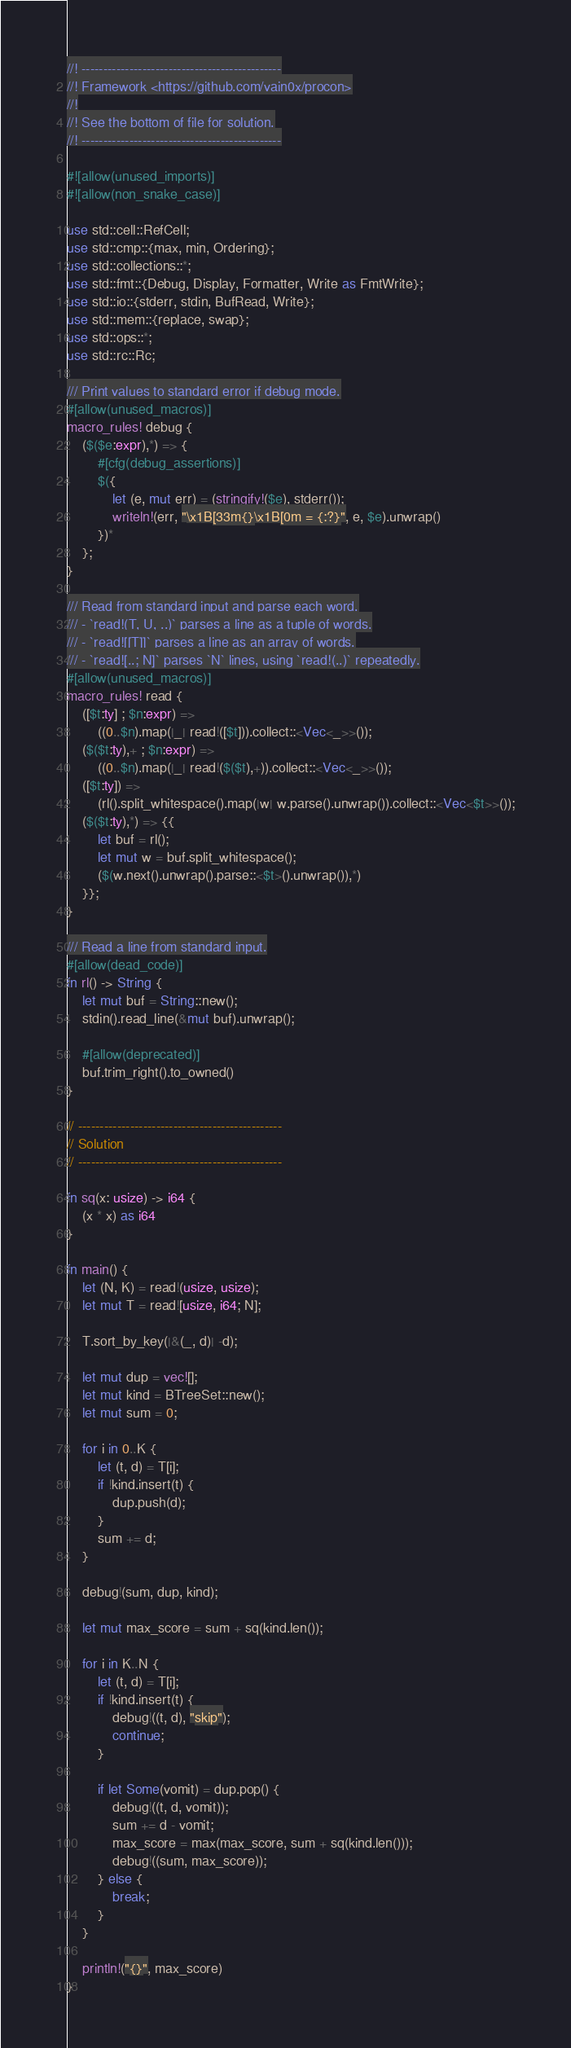<code> <loc_0><loc_0><loc_500><loc_500><_Rust_>//! ----------------------------------------------
//! Framework <https://github.com/vain0x/procon>
//!
//! See the bottom of file for solution.
//! ----------------------------------------------

#![allow(unused_imports)]
#![allow(non_snake_case)]

use std::cell::RefCell;
use std::cmp::{max, min, Ordering};
use std::collections::*;
use std::fmt::{Debug, Display, Formatter, Write as FmtWrite};
use std::io::{stderr, stdin, BufRead, Write};
use std::mem::{replace, swap};
use std::ops::*;
use std::rc::Rc;

/// Print values to standard error if debug mode.
#[allow(unused_macros)]
macro_rules! debug {
    ($($e:expr),*) => {
        #[cfg(debug_assertions)]
        $({
            let (e, mut err) = (stringify!($e), stderr());
            writeln!(err, "\x1B[33m{}\x1B[0m = {:?}", e, $e).unwrap()
        })*
    };
}

/// Read from standard input and parse each word.
/// - `read!(T, U, ..)` parses a line as a tuple of words.
/// - `read![[T]]` parses a line as an array of words.
/// - `read![..; N]` parses `N` lines, using `read!(..)` repeatedly.
#[allow(unused_macros)]
macro_rules! read {
    ([$t:ty] ; $n:expr) =>
        ((0..$n).map(|_| read!([$t])).collect::<Vec<_>>());
    ($($t:ty),+ ; $n:expr) =>
        ((0..$n).map(|_| read!($($t),+)).collect::<Vec<_>>());
    ([$t:ty]) =>
        (rl().split_whitespace().map(|w| w.parse().unwrap()).collect::<Vec<$t>>());
    ($($t:ty),*) => {{
        let buf = rl();
        let mut w = buf.split_whitespace();
        ($(w.next().unwrap().parse::<$t>().unwrap()),*)
    }};
}

/// Read a line from standard input.
#[allow(dead_code)]
fn rl() -> String {
    let mut buf = String::new();
    stdin().read_line(&mut buf).unwrap();

    #[allow(deprecated)]
    buf.trim_right().to_owned()
}

// -----------------------------------------------
// Solution
// -----------------------------------------------

fn sq(x: usize) -> i64 {
    (x * x) as i64
}

fn main() {
    let (N, K) = read!(usize, usize);
    let mut T = read![usize, i64; N];

    T.sort_by_key(|&(_, d)| -d);

    let mut dup = vec![];
    let mut kind = BTreeSet::new();
    let mut sum = 0;

    for i in 0..K {
        let (t, d) = T[i];
        if !kind.insert(t) {
            dup.push(d);
        }
        sum += d;
    }

    debug!(sum, dup, kind);

    let mut max_score = sum + sq(kind.len());

    for i in K..N {
        let (t, d) = T[i];
        if !kind.insert(t) {
            debug!((t, d), "skip");
            continue;
        }

        if let Some(vomit) = dup.pop() {
            debug!((t, d, vomit));
            sum += d - vomit;
            max_score = max(max_score, sum + sq(kind.len()));
            debug!((sum, max_score));
        } else {
            break;
        }
    }

    println!("{}", max_score)
}
</code> 